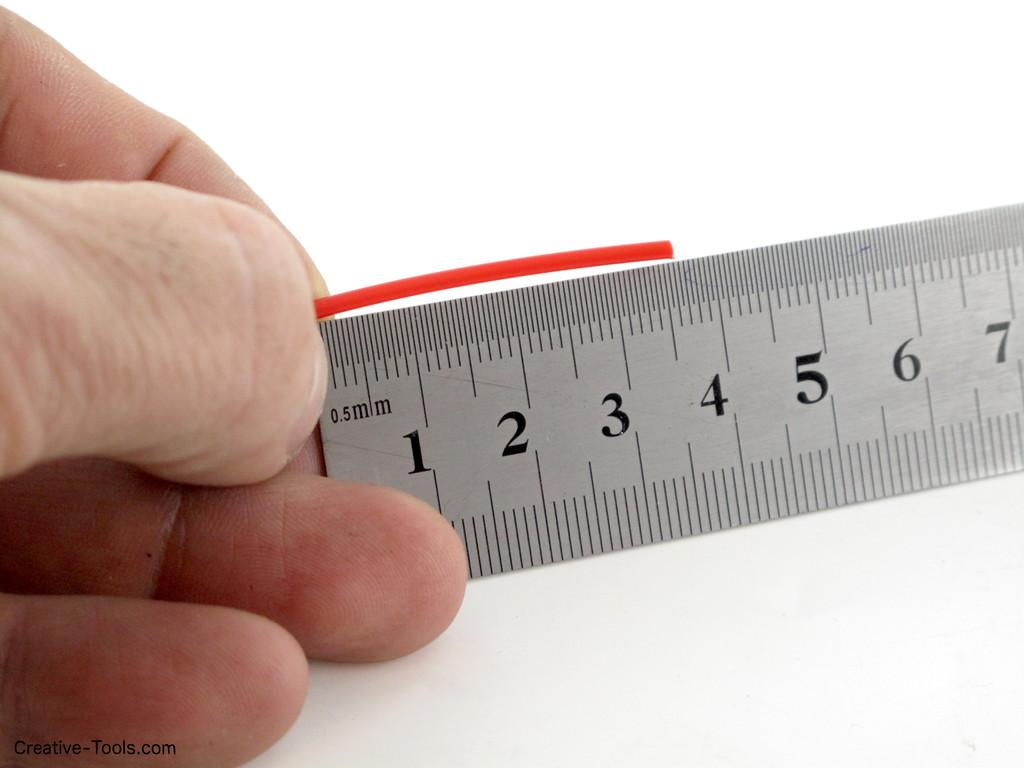Provide a one-sentence caption for the provided image. A ruler displays a 0.5 millimeter measurement at its end. 